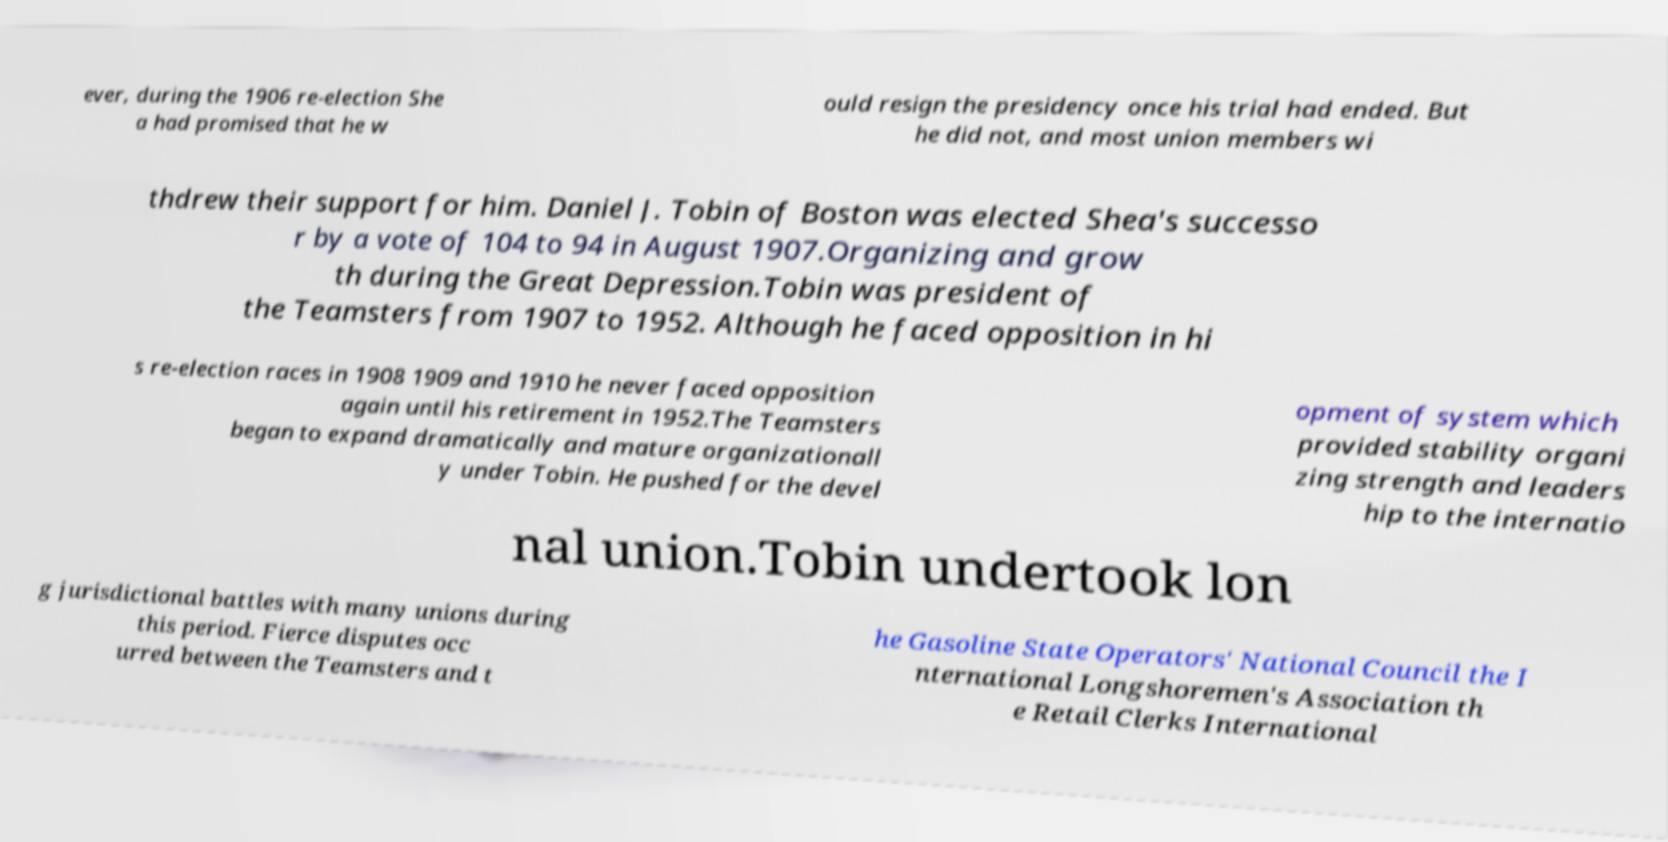I need the written content from this picture converted into text. Can you do that? ever, during the 1906 re-election She a had promised that he w ould resign the presidency once his trial had ended. But he did not, and most union members wi thdrew their support for him. Daniel J. Tobin of Boston was elected Shea's successo r by a vote of 104 to 94 in August 1907.Organizing and grow th during the Great Depression.Tobin was president of the Teamsters from 1907 to 1952. Although he faced opposition in hi s re-election races in 1908 1909 and 1910 he never faced opposition again until his retirement in 1952.The Teamsters began to expand dramatically and mature organizationall y under Tobin. He pushed for the devel opment of system which provided stability organi zing strength and leaders hip to the internatio nal union.Tobin undertook lon g jurisdictional battles with many unions during this period. Fierce disputes occ urred between the Teamsters and t he Gasoline State Operators' National Council the I nternational Longshoremen's Association th e Retail Clerks International 